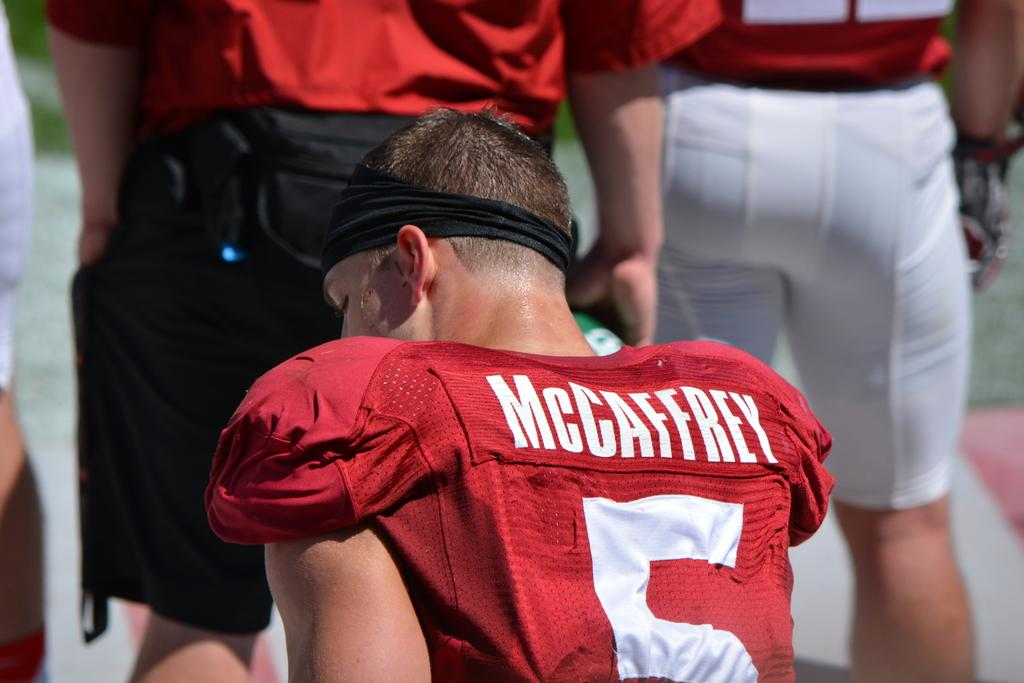<image>
Summarize the visual content of the image. Football player number 5 McCaffrey sitting on the bench. 